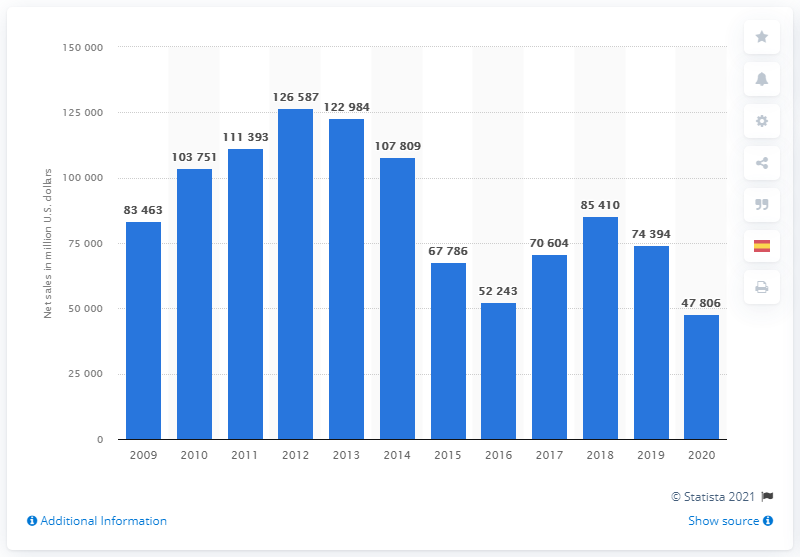Identify some key points in this picture. Pemex's net sales in 2020 were 47,806. 